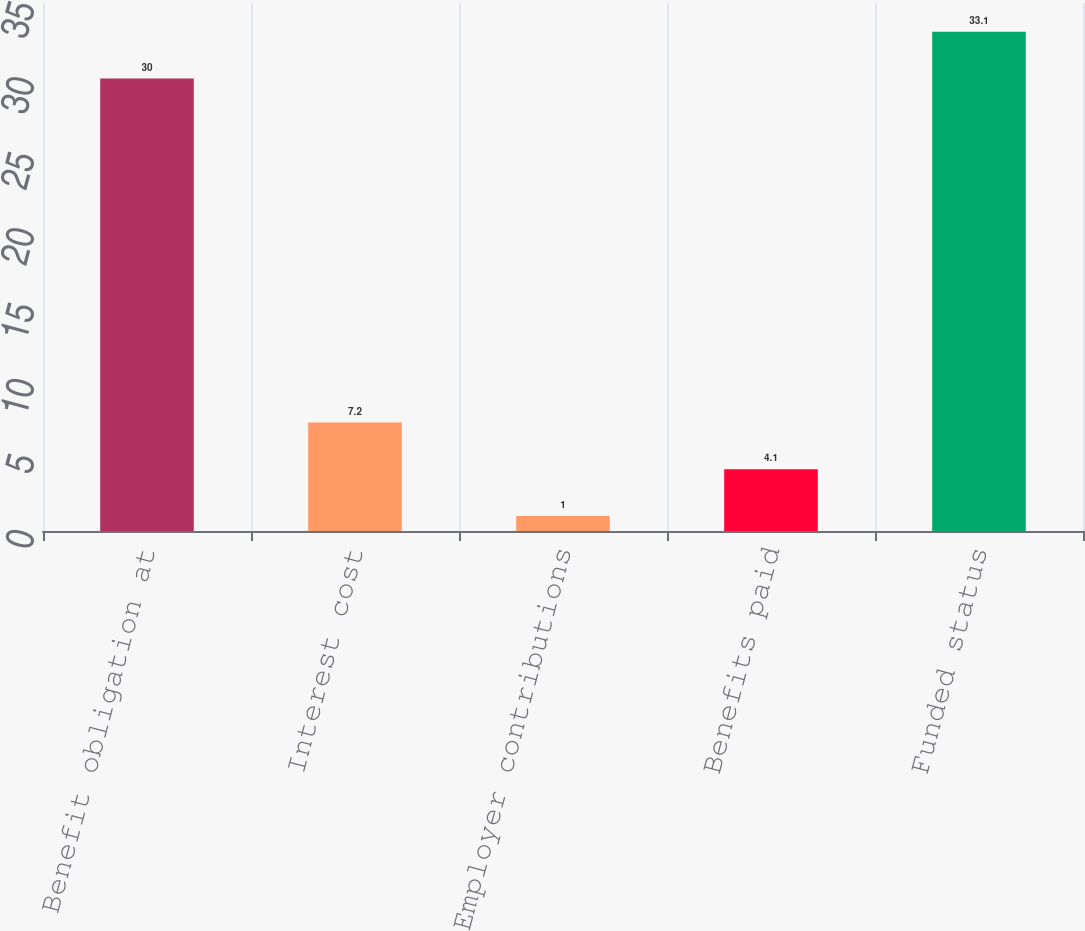Convert chart. <chart><loc_0><loc_0><loc_500><loc_500><bar_chart><fcel>Benefit obligation at<fcel>Interest cost<fcel>Employer contributions<fcel>Benefits paid<fcel>Funded status<nl><fcel>30<fcel>7.2<fcel>1<fcel>4.1<fcel>33.1<nl></chart> 